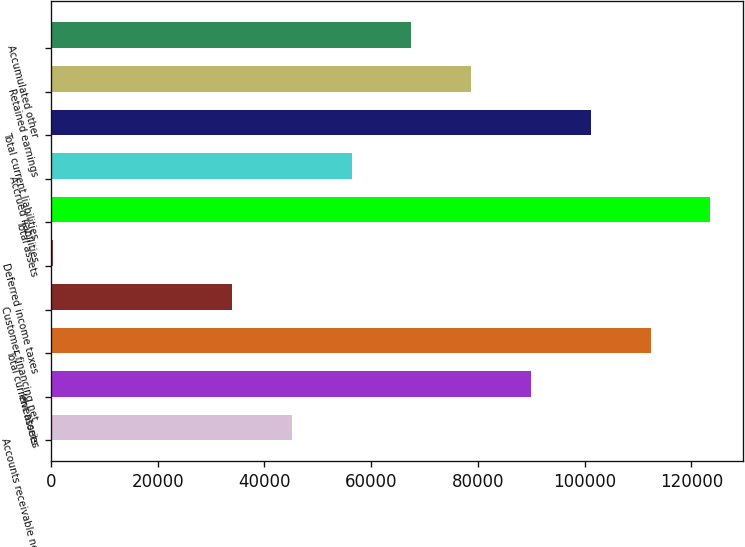<chart> <loc_0><loc_0><loc_500><loc_500><bar_chart><fcel>Accounts receivable net<fcel>Inventories<fcel>Total current assets<fcel>Customer financing net<fcel>Deferred income taxes<fcel>Total assets<fcel>Accrued liabilities<fcel>Total current liabilities<fcel>Retained earnings<fcel>Accumulated other<nl><fcel>45137.4<fcel>89953.8<fcel>112362<fcel>33933.3<fcel>321<fcel>123566<fcel>56341.5<fcel>101158<fcel>78749.7<fcel>67545.6<nl></chart> 